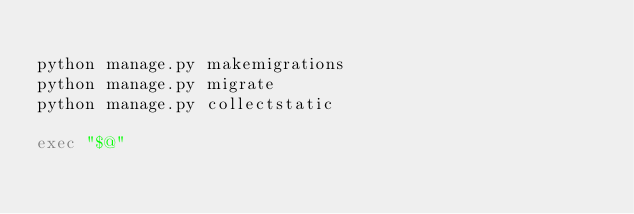Convert code to text. <code><loc_0><loc_0><loc_500><loc_500><_Bash_>
python manage.py makemigrations
python manage.py migrate
python manage.py collectstatic

exec "$@"
</code> 